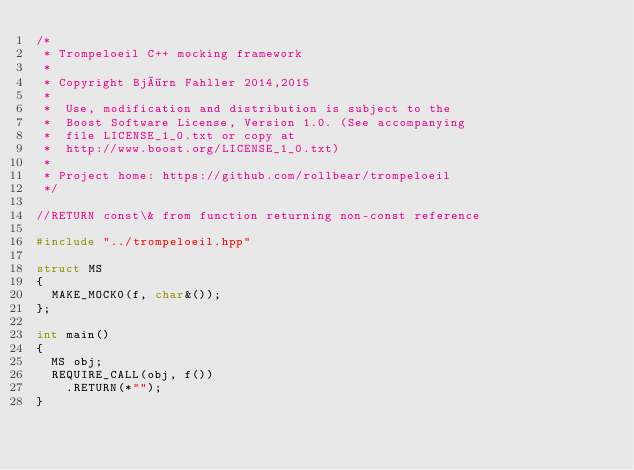Convert code to text. <code><loc_0><loc_0><loc_500><loc_500><_C++_>/*
 * Trompeloeil C++ mocking framework
 *
 * Copyright Björn Fahller 2014,2015
 *
 *  Use, modification and distribution is subject to the
 *  Boost Software License, Version 1.0. (See accompanying
 *  file LICENSE_1_0.txt or copy at
 *  http://www.boost.org/LICENSE_1_0.txt)
 *
 * Project home: https://github.com/rollbear/trompeloeil
 */

//RETURN const\& from function returning non-const reference

#include "../trompeloeil.hpp"

struct MS
{
  MAKE_MOCK0(f, char&());
};

int main()
{
  MS obj;
  REQUIRE_CALL(obj, f())
    .RETURN(*"");
}
</code> 